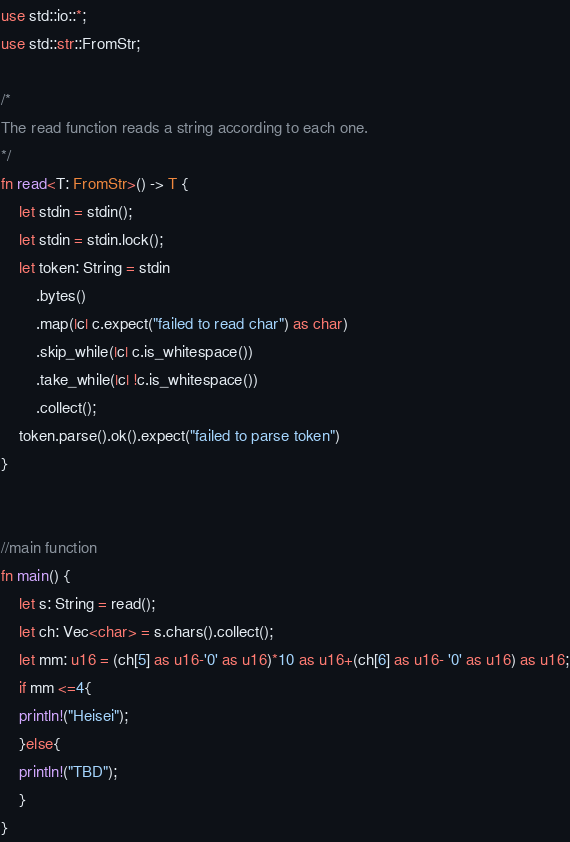<code> <loc_0><loc_0><loc_500><loc_500><_Rust_>use std::io::*;
use std::str::FromStr;
 
/* 
The read function reads a string according to each one. 
*/
fn read<T: FromStr>() -> T {
    let stdin = stdin();
    let stdin = stdin.lock();
    let token: String = stdin
        .bytes()
        .map(|c| c.expect("failed to read char") as char) 
        .skip_while(|c| c.is_whitespace())
        .take_while(|c| !c.is_whitespace())
        .collect();
    token.parse().ok().expect("failed to parse token")
}


//main function
fn main() {
    let s: String = read();
    let ch: Vec<char> = s.chars().collect();
    let mm: u16 = (ch[5] as u16-'0' as u16)*10 as u16+(ch[6] as u16- '0' as u16) as u16;
    if mm <=4{
	println!("Heisei");
    }else{
	println!("TBD");
    }
}
</code> 